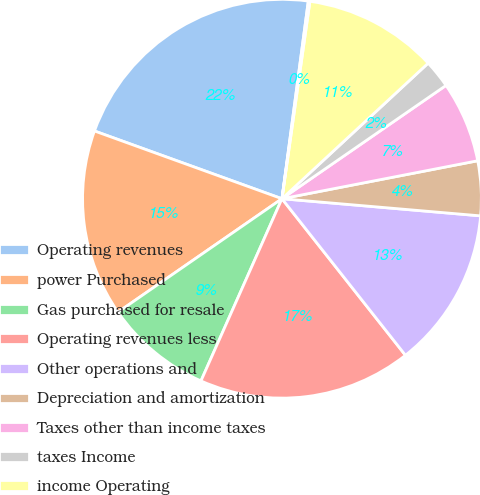<chart> <loc_0><loc_0><loc_500><loc_500><pie_chart><fcel>Operating revenues<fcel>power Purchased<fcel>Gas purchased for resale<fcel>Operating revenues less<fcel>Other operations and<fcel>Depreciation and amortization<fcel>Taxes other than income taxes<fcel>taxes Income<fcel>income Operating<fcel>expense interest Net<nl><fcel>21.59%<fcel>15.15%<fcel>8.71%<fcel>17.29%<fcel>13.0%<fcel>4.42%<fcel>6.57%<fcel>2.28%<fcel>10.86%<fcel>0.13%<nl></chart> 